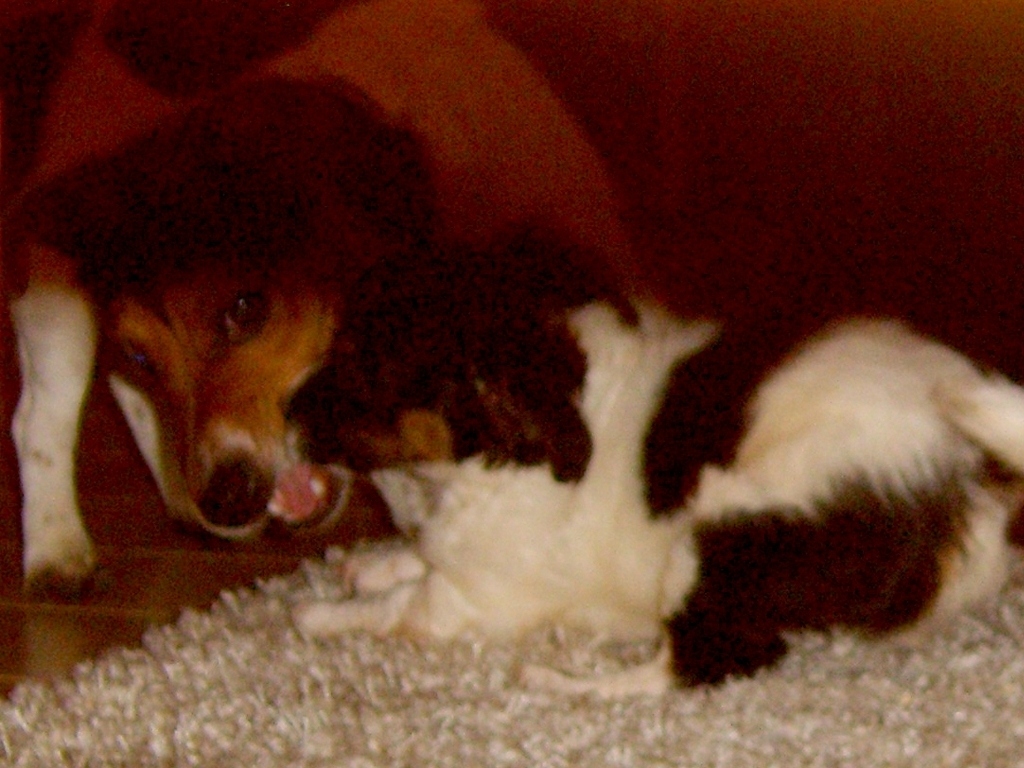How would you describe the content of the image?
A. Relatively complete
B. Overcrowded
C. Incomplete
Answer with the option's letter from the given choices directly. A. The image is best described as 'Relatively complete'. It showcases a scene where two pets, possibly a dog and a cat, are engaging closely, likely playing or showing affection, without any significant elements missing that would otherwise suggest an incomplete depiction. 